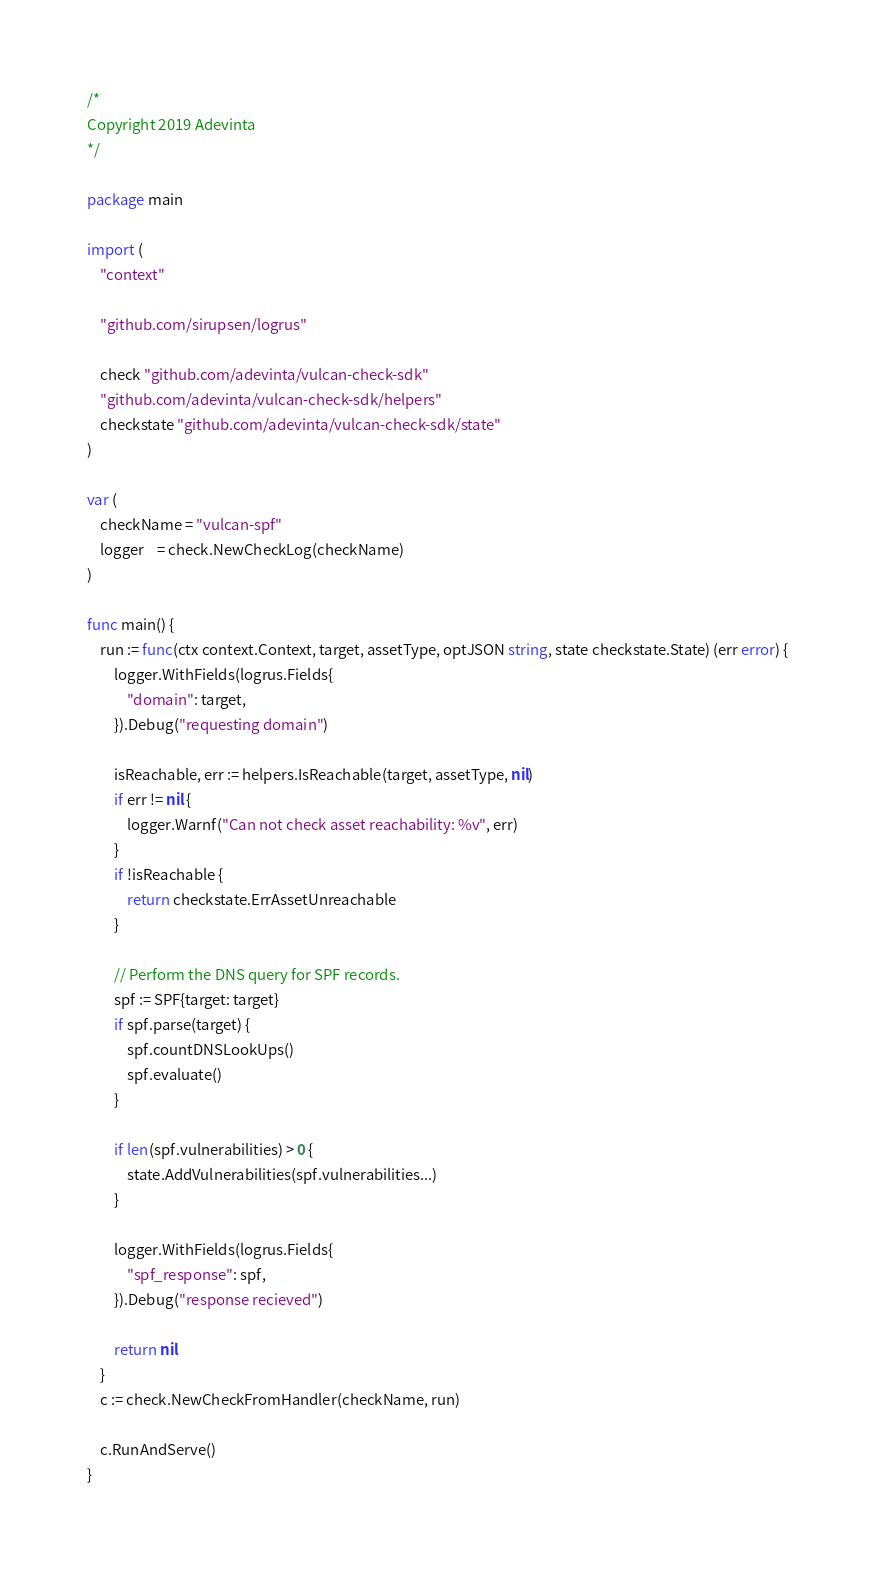<code> <loc_0><loc_0><loc_500><loc_500><_Go_>/*
Copyright 2019 Adevinta
*/

package main

import (
	"context"

	"github.com/sirupsen/logrus"

	check "github.com/adevinta/vulcan-check-sdk"
	"github.com/adevinta/vulcan-check-sdk/helpers"
	checkstate "github.com/adevinta/vulcan-check-sdk/state"
)

var (
	checkName = "vulcan-spf"
	logger    = check.NewCheckLog(checkName)
)

func main() {
	run := func(ctx context.Context, target, assetType, optJSON string, state checkstate.State) (err error) {
		logger.WithFields(logrus.Fields{
			"domain": target,
		}).Debug("requesting domain")

		isReachable, err := helpers.IsReachable(target, assetType, nil)
		if err != nil {
			logger.Warnf("Can not check asset reachability: %v", err)
		}
		if !isReachable {
			return checkstate.ErrAssetUnreachable
		}

		// Perform the DNS query for SPF records.
		spf := SPF{target: target}
		if spf.parse(target) {
			spf.countDNSLookUps()
			spf.evaluate()
		}

		if len(spf.vulnerabilities) > 0 {
			state.AddVulnerabilities(spf.vulnerabilities...)
		}

		logger.WithFields(logrus.Fields{
			"spf_response": spf,
		}).Debug("response recieved")

		return nil
	}
	c := check.NewCheckFromHandler(checkName, run)

	c.RunAndServe()
}
</code> 